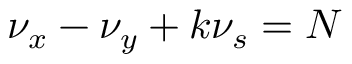<formula> <loc_0><loc_0><loc_500><loc_500>\nu _ { x } - \nu _ { y } + k \nu _ { s } = N</formula> 